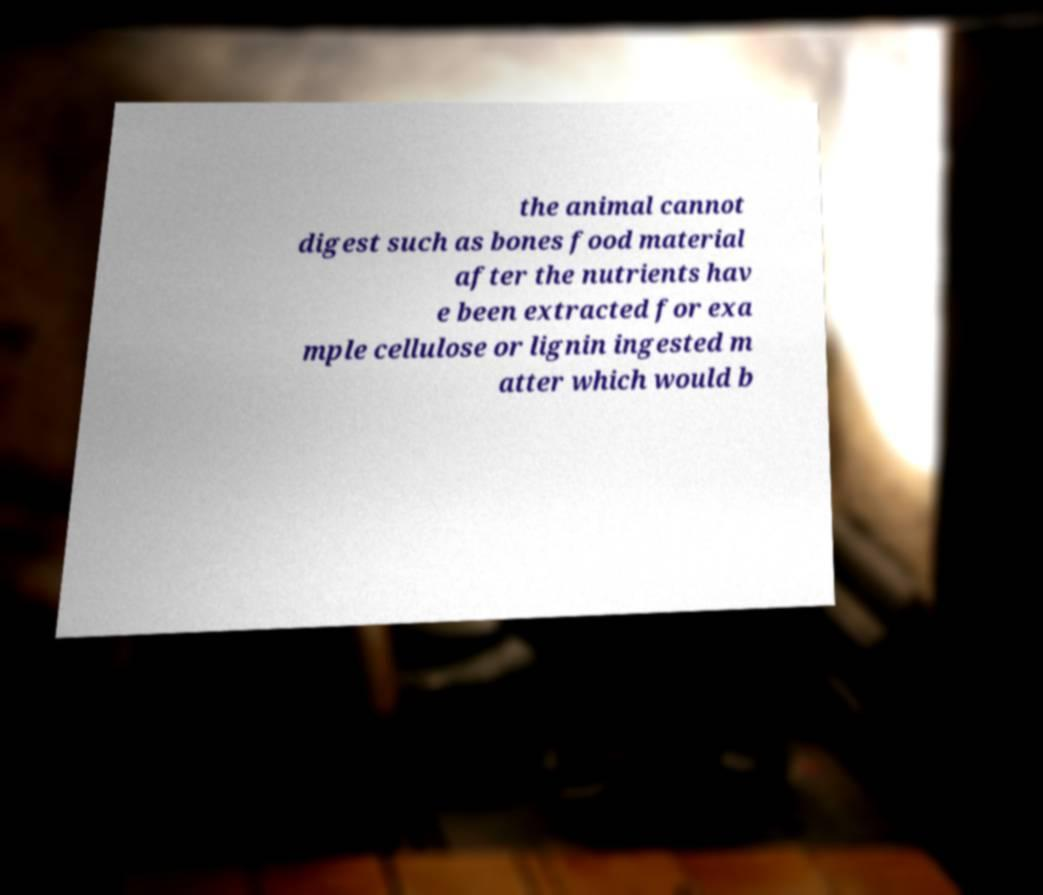Could you extract and type out the text from this image? the animal cannot digest such as bones food material after the nutrients hav e been extracted for exa mple cellulose or lignin ingested m atter which would b 